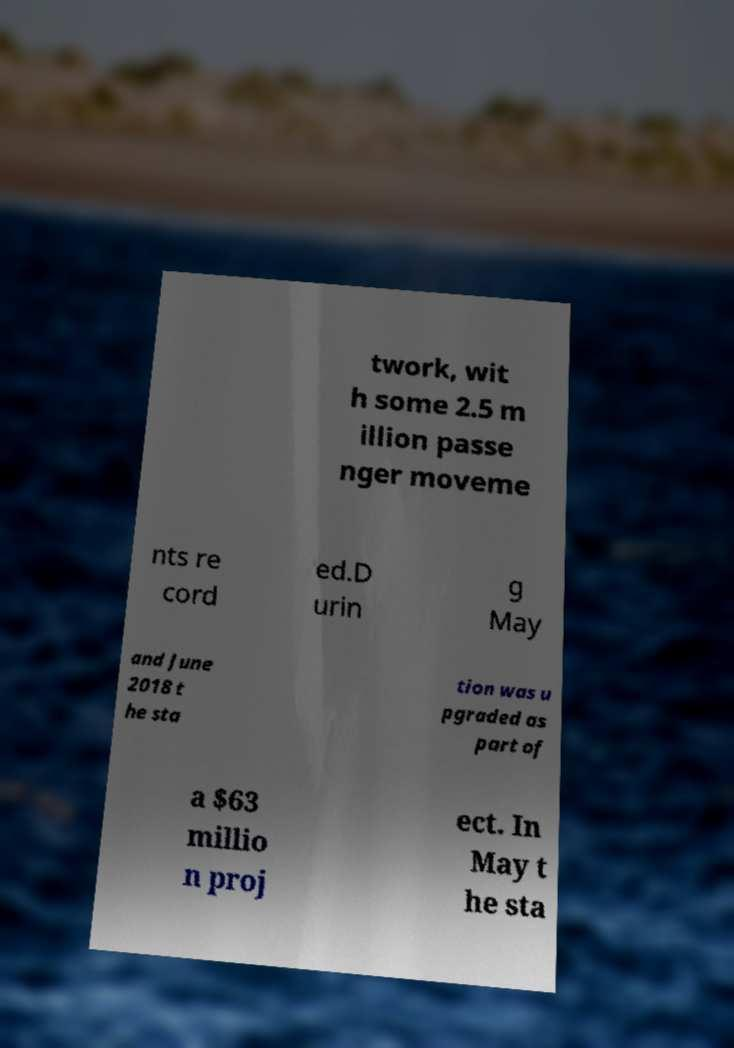Can you read and provide the text displayed in the image?This photo seems to have some interesting text. Can you extract and type it out for me? twork, wit h some 2.5 m illion passe nger moveme nts re cord ed.D urin g May and June 2018 t he sta tion was u pgraded as part of a $63 millio n proj ect. In May t he sta 